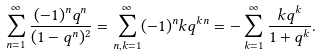<formula> <loc_0><loc_0><loc_500><loc_500>\sum _ { n = 1 } ^ { \infty } \frac { ( - 1 ) ^ { n } q ^ { n } } { ( 1 - q ^ { n } ) ^ { 2 } } = \sum _ { n , k = 1 } ^ { \infty } ( - 1 ) ^ { n } k q ^ { k n } = - \sum _ { k = 1 } ^ { \infty } \frac { k q ^ { k } } { 1 + q ^ { k } } .</formula> 